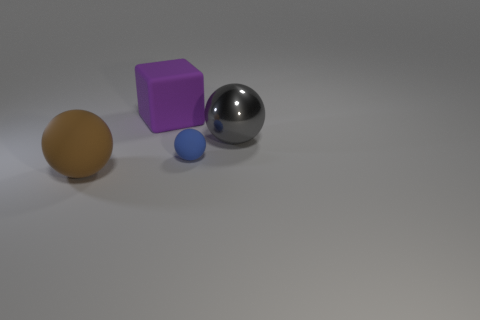Add 4 tiny blue rubber spheres. How many objects exist? 8 Subtract all large metallic balls. How many balls are left? 2 Subtract all gray balls. How many balls are left? 2 Subtract all spheres. How many objects are left? 1 Subtract 1 cubes. How many cubes are left? 0 Add 1 tiny blue matte things. How many tiny blue matte things exist? 2 Subtract 0 purple cylinders. How many objects are left? 4 Subtract all purple spheres. Subtract all cyan cylinders. How many spheres are left? 3 Subtract all gray blocks. How many gray balls are left? 1 Subtract all big yellow metallic cylinders. Subtract all big purple cubes. How many objects are left? 3 